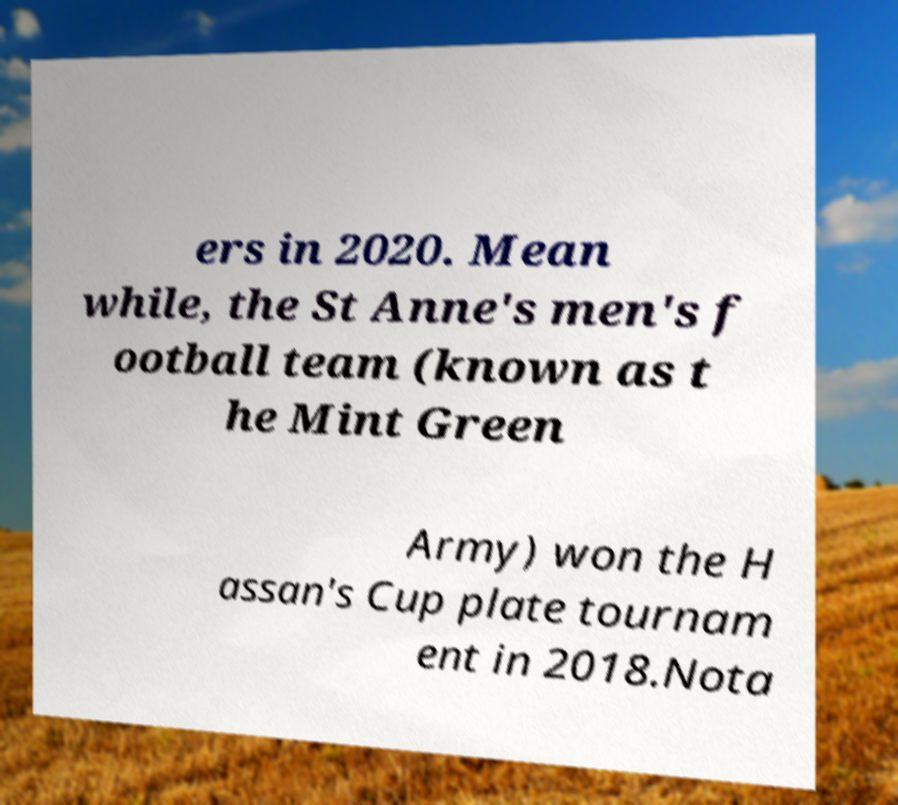Please read and relay the text visible in this image. What does it say? ers in 2020. Mean while, the St Anne's men's f ootball team (known as t he Mint Green Army) won the H assan's Cup plate tournam ent in 2018.Nota 